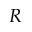Convert formula to latex. <formula><loc_0><loc_0><loc_500><loc_500>R</formula> 